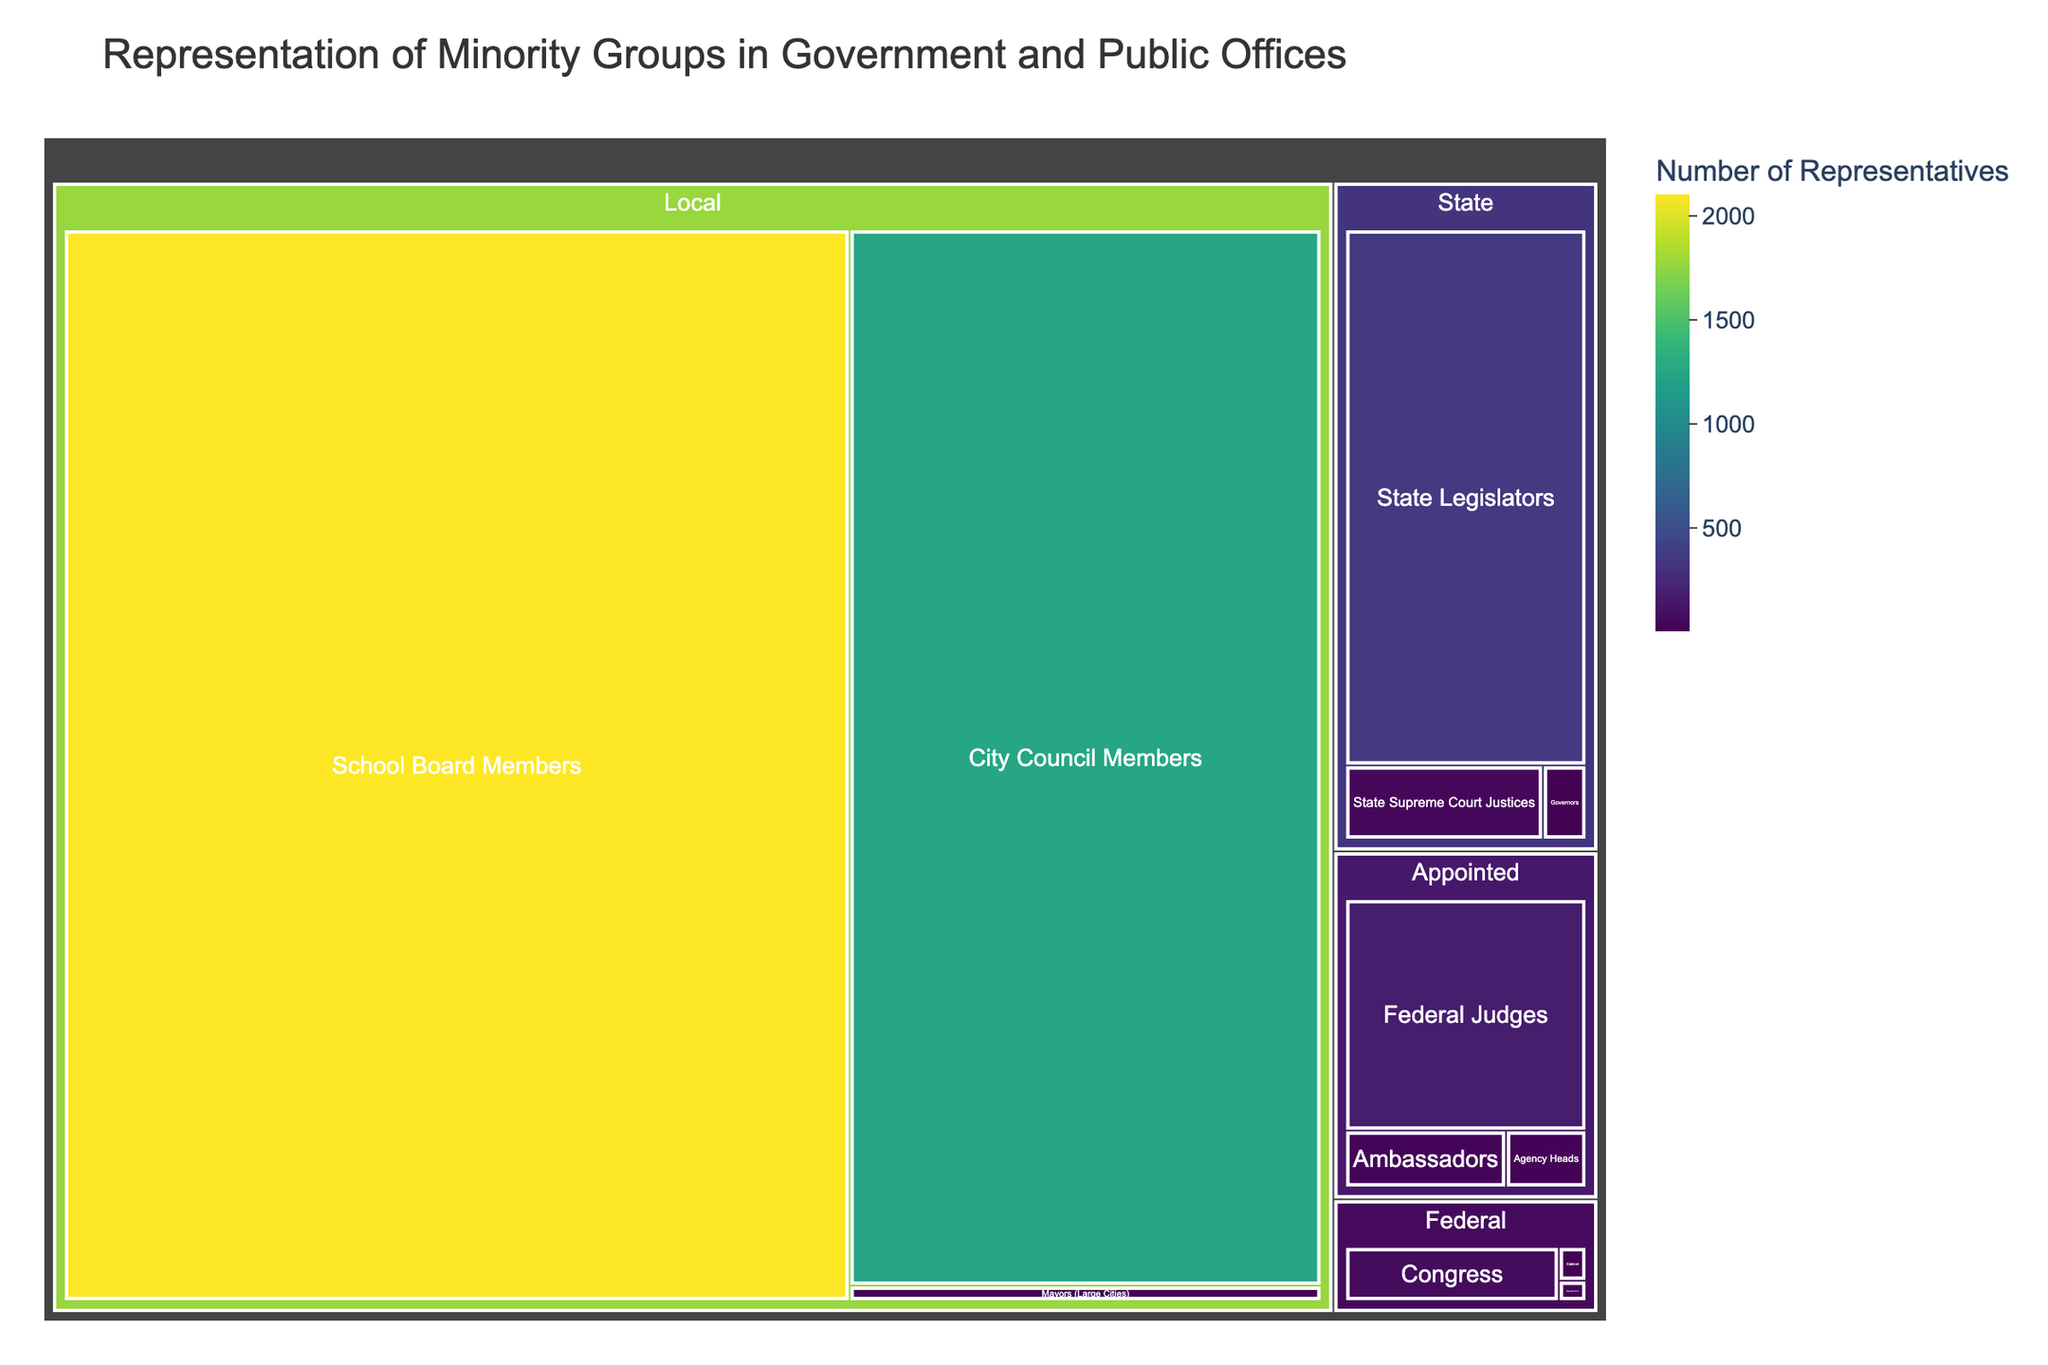How many categories are represented on the treemap? The treemap is divided into categories such as Federal, State, Local, and Appointed. By looking at the section headers, you can count four distinct categories.
Answer: Four Which category has the highest number of representatives in a single subcategory? Observe the values for each category and find the highest number within any subcategory. The Local category’s "School Board Members" has the highest count with 2103 representatives.
Answer: Local What is the total number of representatives at the Federal level? Sum up the values within the Federal category: Congress (62) + Cabinet (5) + Supreme Court (3) equals 70.
Answer: 70 Which subcategory under the State category has the smallest representation? Compare the values under the State category and identify the smallest one: Governors (9).
Answer: Governors How does the number of City Council Members compare to State Legislators? Compare the values: City Council Members have 1245, while State Legislators have 362. City Council Members (1245) is greater than State Legislators (362).
Answer: 1245 is greater than 362 What is the combined total of representatives for all Local subcategories? Add the values under Local: Mayors (18) + City Council Members (1245) + School Board Members (2103) equals 3366.
Answer: 3366 What proportion of Federal Judges to Federal Congressional members is observed? Divide the number of Federal Judges (172) by the number of Congressional members (62): 172/62 ≈ 2.774.
Answer: Approximately 2.774 Which has more representation: Appointed Federal Judges or State Supreme Court Justices? Compare the values: Federal Judges (172) are more than State Supreme Court Justices (41).
Answer: Appointed Federal Judges Among the subcategories under Appointed, which has the lowest representation and what value is it? Identify the subcategory with the lowest value under Appointed. Agency Heads have the lowest with 14 representatives.
Answer: Agency Heads, 14 What's the difference between the number of Ambassadors and Agency Heads? Subtract the number of Agency Heads (14) from Ambassadors (28): 28 - 14 = 14.
Answer: 14 